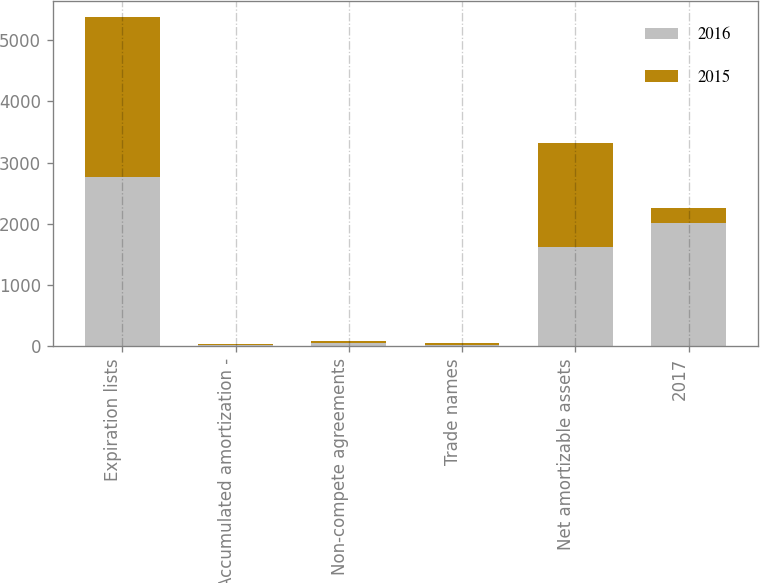Convert chart to OTSL. <chart><loc_0><loc_0><loc_500><loc_500><stacked_bar_chart><ecel><fcel>Expiration lists<fcel>Accumulated amortization -<fcel>Non-compete agreements<fcel>Trade names<fcel>Net amortizable assets<fcel>2017<nl><fcel>2016<fcel>2757.6<fcel>18.5<fcel>49.3<fcel>24<fcel>1627.3<fcel>2017<nl><fcel>2015<fcel>2613.3<fcel>14.4<fcel>43.7<fcel>25.7<fcel>1698.8<fcel>239.6<nl></chart> 